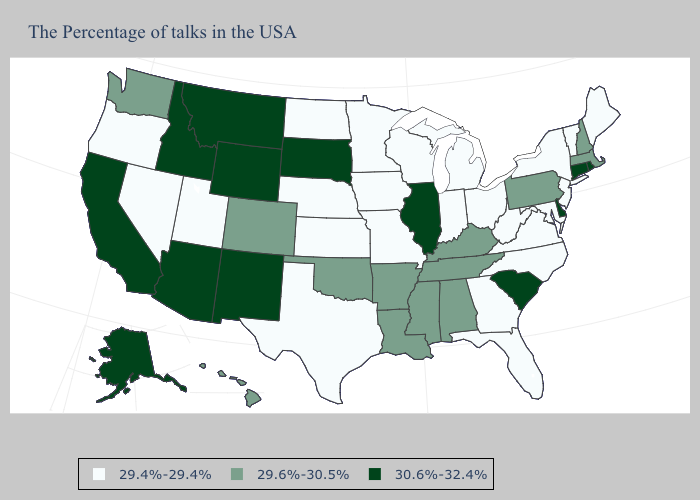What is the value of Virginia?
Be succinct. 29.4%-29.4%. Does the map have missing data?
Keep it brief. No. Name the states that have a value in the range 29.4%-29.4%?
Keep it brief. Maine, Vermont, New York, New Jersey, Maryland, Virginia, North Carolina, West Virginia, Ohio, Florida, Georgia, Michigan, Indiana, Wisconsin, Missouri, Minnesota, Iowa, Kansas, Nebraska, Texas, North Dakota, Utah, Nevada, Oregon. Among the states that border Mississippi , which have the highest value?
Quick response, please. Alabama, Tennessee, Louisiana, Arkansas. Name the states that have a value in the range 29.4%-29.4%?
Concise answer only. Maine, Vermont, New York, New Jersey, Maryland, Virginia, North Carolina, West Virginia, Ohio, Florida, Georgia, Michigan, Indiana, Wisconsin, Missouri, Minnesota, Iowa, Kansas, Nebraska, Texas, North Dakota, Utah, Nevada, Oregon. Does Rhode Island have the highest value in the Northeast?
Keep it brief. Yes. What is the value of Mississippi?
Short answer required. 29.6%-30.5%. What is the lowest value in the USA?
Answer briefly. 29.4%-29.4%. Name the states that have a value in the range 29.4%-29.4%?
Keep it brief. Maine, Vermont, New York, New Jersey, Maryland, Virginia, North Carolina, West Virginia, Ohio, Florida, Georgia, Michigan, Indiana, Wisconsin, Missouri, Minnesota, Iowa, Kansas, Nebraska, Texas, North Dakota, Utah, Nevada, Oregon. What is the value of Minnesota?
Be succinct. 29.4%-29.4%. Among the states that border Iowa , does South Dakota have the highest value?
Give a very brief answer. Yes. What is the value of Oregon?
Short answer required. 29.4%-29.4%. Does Virginia have the lowest value in the USA?
Quick response, please. Yes. 